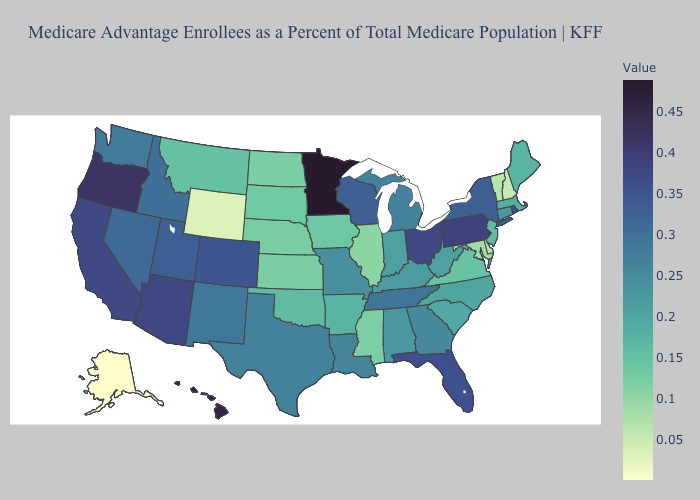Among the states that border Arkansas , does Louisiana have the highest value?
Be succinct. No. Among the states that border Massachusetts , which have the lowest value?
Write a very short answer. New Hampshire. Does Minnesota have the highest value in the USA?
Quick response, please. Yes. Which states have the highest value in the USA?
Quick response, please. Minnesota. Does New Mexico have the highest value in the West?
Keep it brief. No. Among the states that border Vermont , does New York have the highest value?
Give a very brief answer. Yes. Does the map have missing data?
Short answer required. No. Does Missouri have a higher value than New Hampshire?
Keep it brief. Yes. 